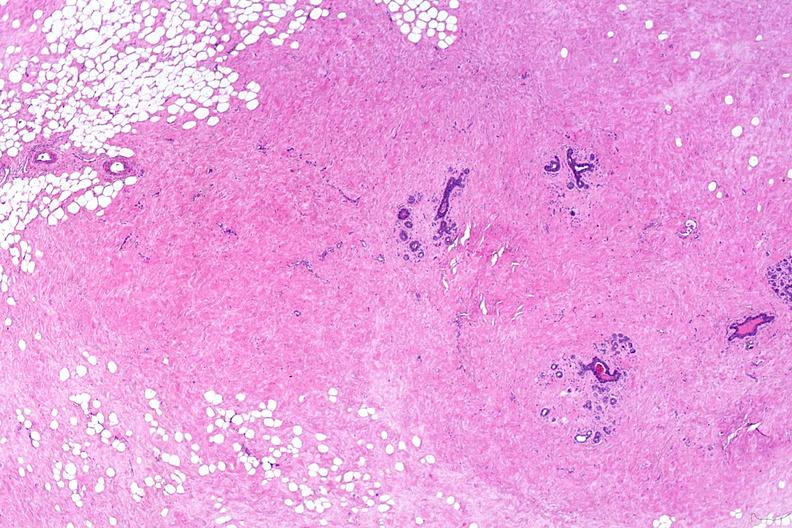what does this image show?
Answer the question using a single word or phrase. Normal breast 